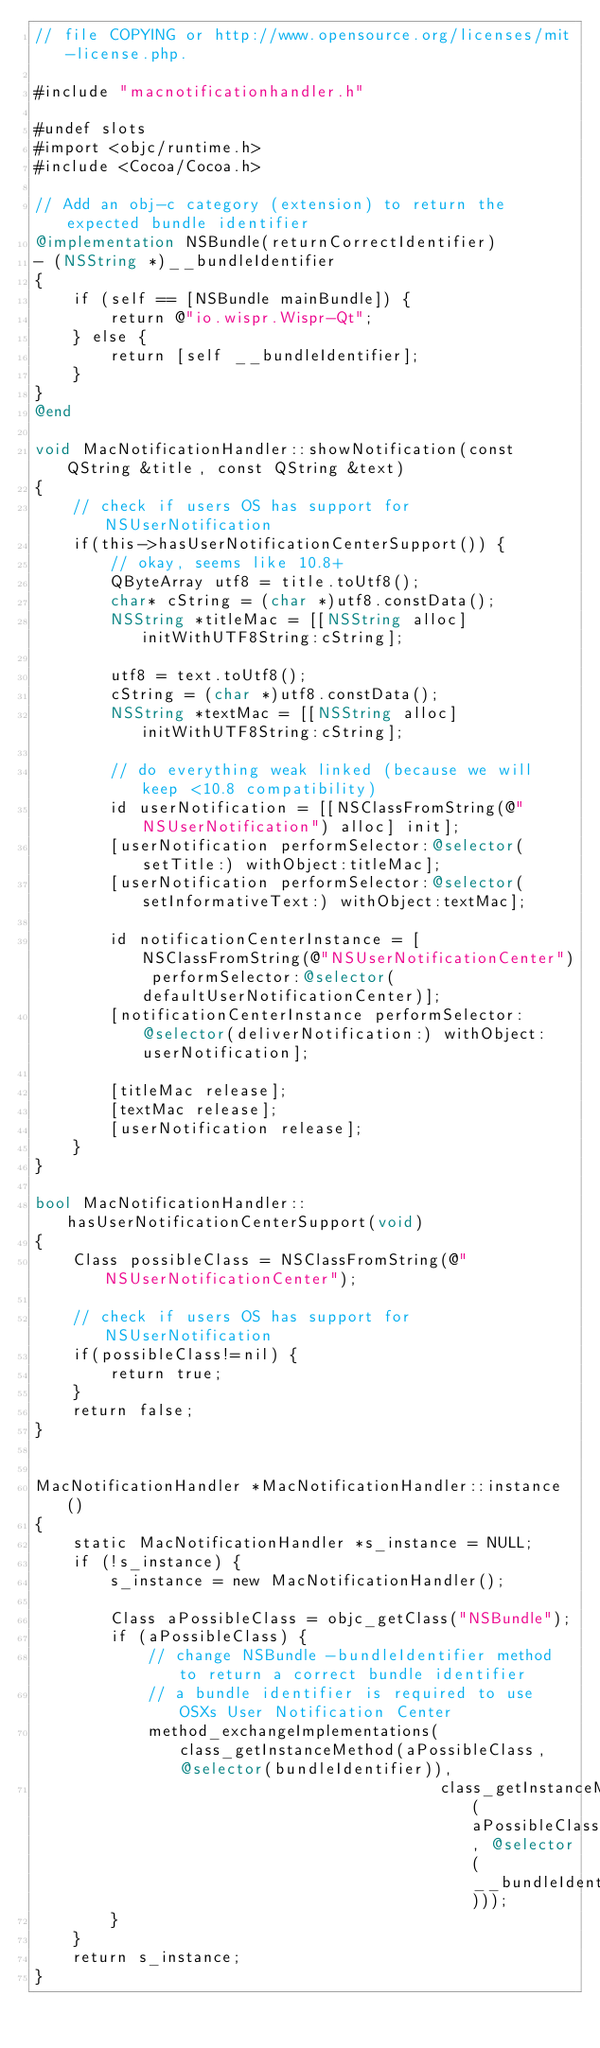Convert code to text. <code><loc_0><loc_0><loc_500><loc_500><_ObjectiveC_>// file COPYING or http://www.opensource.org/licenses/mit-license.php.

#include "macnotificationhandler.h"

#undef slots
#import <objc/runtime.h>
#include <Cocoa/Cocoa.h>

// Add an obj-c category (extension) to return the expected bundle identifier
@implementation NSBundle(returnCorrectIdentifier)
- (NSString *)__bundleIdentifier
{
    if (self == [NSBundle mainBundle]) {
        return @"io.wispr.Wispr-Qt";
    } else {
        return [self __bundleIdentifier];
    }
}
@end

void MacNotificationHandler::showNotification(const QString &title, const QString &text)
{
    // check if users OS has support for NSUserNotification
    if(this->hasUserNotificationCenterSupport()) {
        // okay, seems like 10.8+
        QByteArray utf8 = title.toUtf8();
        char* cString = (char *)utf8.constData();
        NSString *titleMac = [[NSString alloc] initWithUTF8String:cString];

        utf8 = text.toUtf8();
        cString = (char *)utf8.constData();
        NSString *textMac = [[NSString alloc] initWithUTF8String:cString];

        // do everything weak linked (because we will keep <10.8 compatibility)
        id userNotification = [[NSClassFromString(@"NSUserNotification") alloc] init];
        [userNotification performSelector:@selector(setTitle:) withObject:titleMac];
        [userNotification performSelector:@selector(setInformativeText:) withObject:textMac];

        id notificationCenterInstance = [NSClassFromString(@"NSUserNotificationCenter") performSelector:@selector(defaultUserNotificationCenter)];
        [notificationCenterInstance performSelector:@selector(deliverNotification:) withObject:userNotification];

        [titleMac release];
        [textMac release];
        [userNotification release];
    }
}

bool MacNotificationHandler::hasUserNotificationCenterSupport(void)
{
    Class possibleClass = NSClassFromString(@"NSUserNotificationCenter");

    // check if users OS has support for NSUserNotification
    if(possibleClass!=nil) {
        return true;
    }
    return false;
}


MacNotificationHandler *MacNotificationHandler::instance()
{
    static MacNotificationHandler *s_instance = NULL;
    if (!s_instance) {
        s_instance = new MacNotificationHandler();
        
        Class aPossibleClass = objc_getClass("NSBundle");
        if (aPossibleClass) {
            // change NSBundle -bundleIdentifier method to return a correct bundle identifier
            // a bundle identifier is required to use OSXs User Notification Center
            method_exchangeImplementations(class_getInstanceMethod(aPossibleClass, @selector(bundleIdentifier)),
                                           class_getInstanceMethod(aPossibleClass, @selector(__bundleIdentifier)));
        }
    }
    return s_instance;
}
</code> 